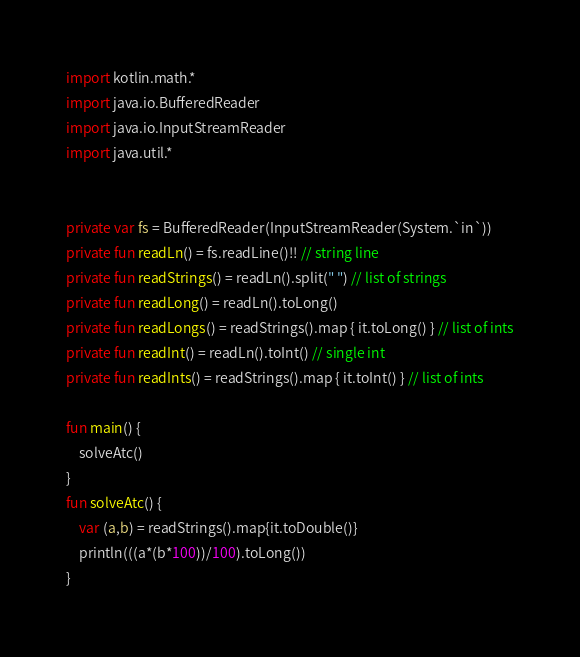<code> <loc_0><loc_0><loc_500><loc_500><_Kotlin_>import kotlin.math.*
import java.io.BufferedReader
import java.io.InputStreamReader
import java.util.*


private var fs = BufferedReader(InputStreamReader(System.`in`))
private fun readLn() = fs.readLine()!! // string line
private fun readStrings() = readLn().split(" ") // list of strings
private fun readLong() = readLn().toLong()
private fun readLongs() = readStrings().map { it.toLong() } // list of ints
private fun readInt() = readLn().toInt() // single int
private fun readInts() = readStrings().map { it.toInt() } // list of ints

fun main() {
    solveAtc()
}
fun solveAtc() {
    var (a,b) = readStrings().map{it.toDouble()}
    println(((a*(b*100))/100).toLong())
}</code> 